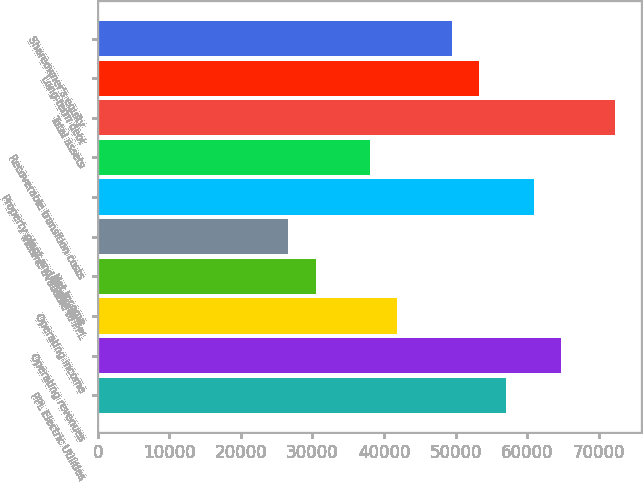Convert chart. <chart><loc_0><loc_0><loc_500><loc_500><bar_chart><fcel>PPL Electric Utilities<fcel>Operating revenues<fcel>Operating income<fcel>Net income<fcel>Income available to PPL<fcel>Property plant and equipment -<fcel>Recoverable transition costs<fcel>Total assets<fcel>Long-term debt<fcel>Shareowner's equity<nl><fcel>57085.7<fcel>64696.7<fcel>41863.5<fcel>30446.9<fcel>26641.4<fcel>60891.2<fcel>38058<fcel>72307.8<fcel>53280.1<fcel>49474.6<nl></chart> 